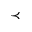<formula> <loc_0><loc_0><loc_500><loc_500>\prec</formula> 